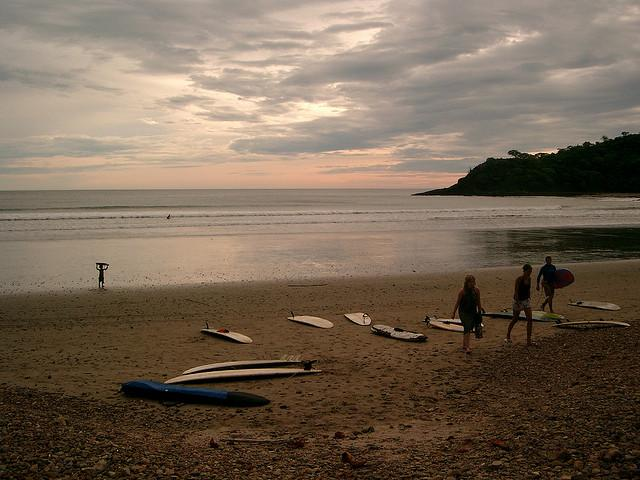Why is he carrying his surfboard?

Choices:
A) stealing it
B) exercise
C) done surfing
D) hiding it done surfing 